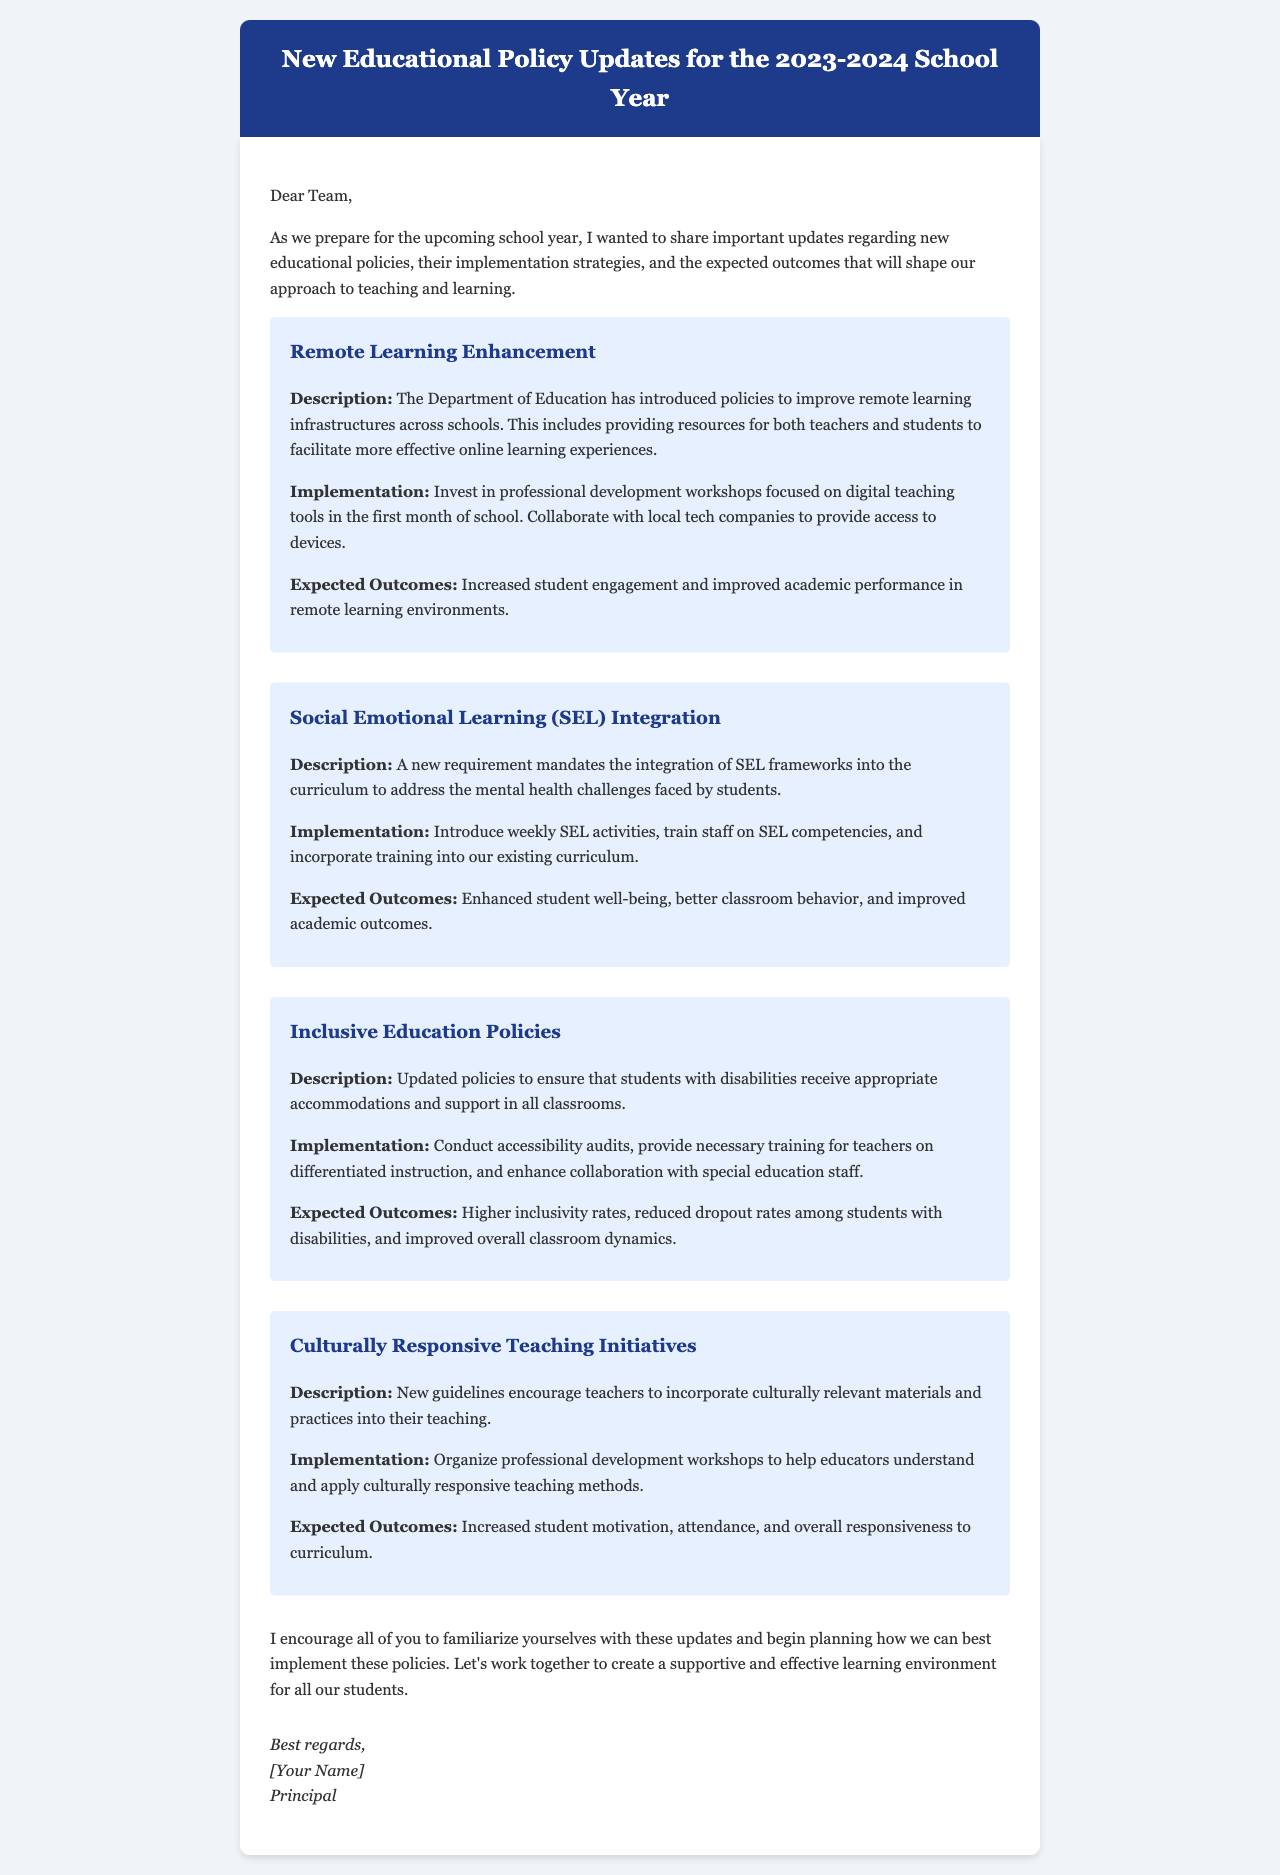What is the title of the document? The title is found in the header section of the document.
Answer: New Educational Policy Updates for the 2023-2024 School Year What policy focuses on integrating SEL frameworks? The question asks for the specific policy name mentioned in the document.
Answer: Social Emotional Learning (SEL) Integration How many new policies are discussed in the document? The document lists four distinct new policies in total.
Answer: Four What is the expected outcome of the Remote Learning Enhancement policy? This refers to the result anticipated from the implementation of the policy outlined in the description.
Answer: Increased student engagement and improved academic performance in remote learning environments Who is the sender of the email? The sender is identified in the signature section of the document.
Answer: [Your Name] 